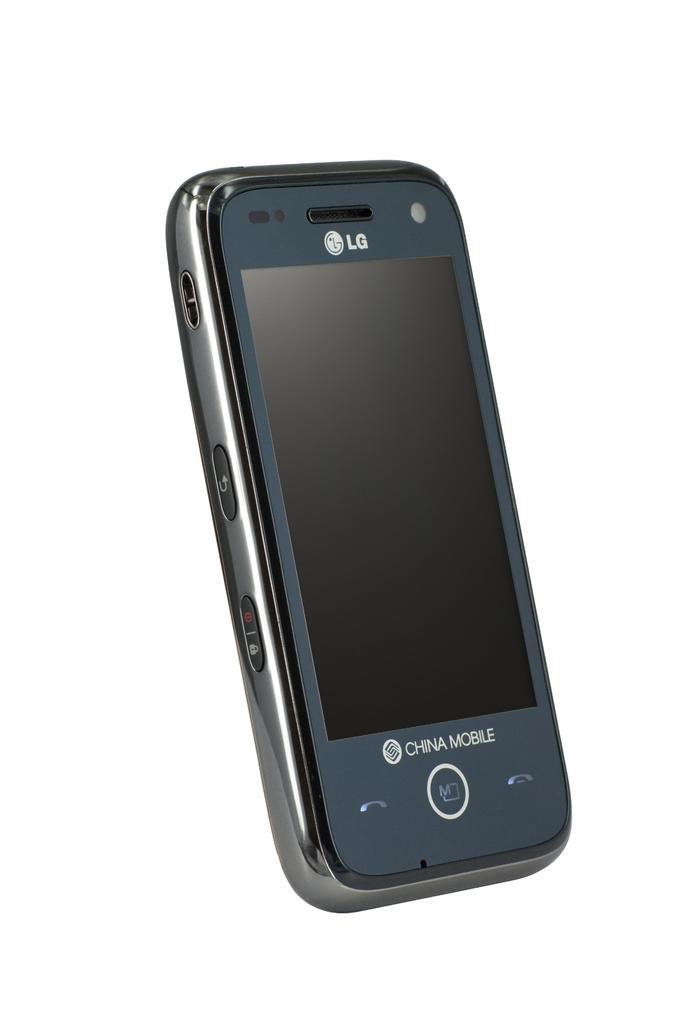<image>
Summarize the visual content of the image. An LG China Mobile cell phone on display. 